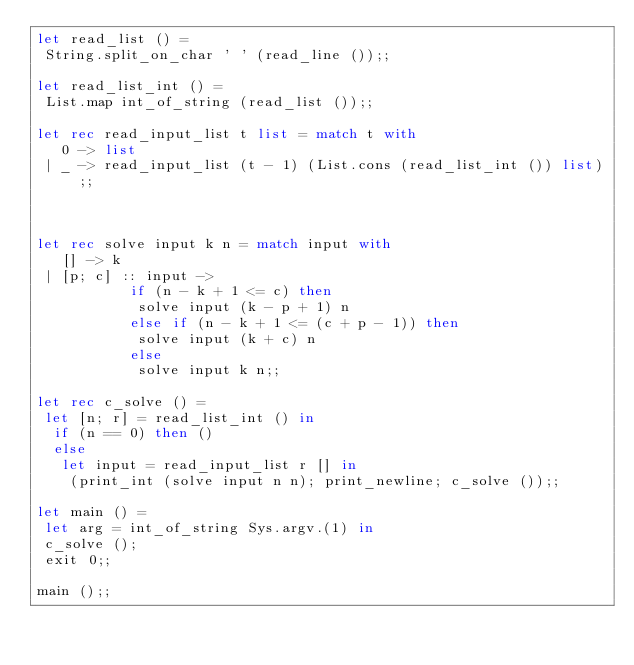<code> <loc_0><loc_0><loc_500><loc_500><_OCaml_>let read_list () =
 String.split_on_char ' ' (read_line ());;

let read_list_int () =
 List.map int_of_string (read_list ());;

let rec read_input_list t list = match t with
   0 -> list
 | _ -> read_input_list (t - 1) (List.cons (read_list_int ()) list);;



let rec solve input k n = match input with
   [] -> k
 | [p; c] :: input ->
           if (n - k + 1 <= c) then
            solve input (k - p + 1) n
           else if (n - k + 1 <= (c + p - 1)) then
            solve input (k + c) n
           else
            solve input k n;;

let rec c_solve () =
 let [n; r] = read_list_int () in
  if (n == 0) then ()
  else
   let input = read_input_list r [] in
    (print_int (solve input n n); print_newline; c_solve ());;

let main () =
 let arg = int_of_string Sys.argv.(1) in
 c_solve ();
 exit 0;;

main ();;

</code> 